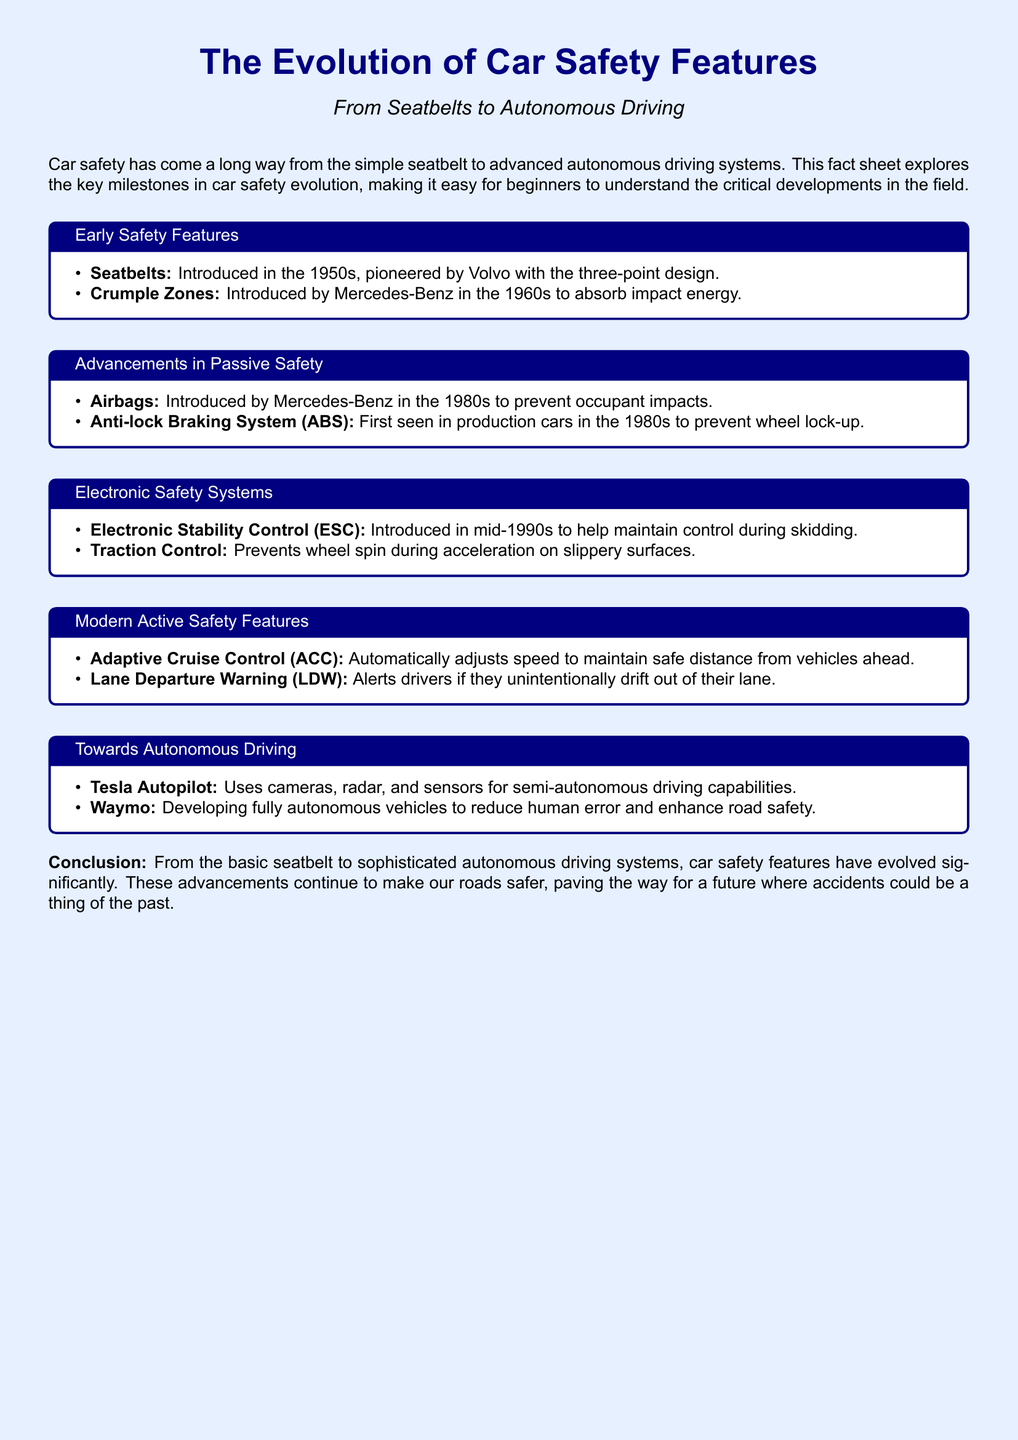What safety feature was introduced in the 1950s? The feature introduced in the 1950s was the seatbelt, pioneered by Volvo with the three-point design.
Answer: Seatbelts Which company introduced crumple zones? Crumple zones were introduced by Mercedes-Benz in the 1960s to absorb impact energy.
Answer: Mercedes-Benz When were airbags first introduced? Airbags were first introduced in the 1980s by Mercedes-Benz to prevent occupant impacts.
Answer: 1980s What does ESC stand for? ESC stands for Electronic Stability Control, introduced in the mid-1990s to help maintain control during skidding.
Answer: Electronic Stability Control What is the purpose of Adaptive Cruise Control? The purpose of Adaptive Cruise Control is to automatically adjust speed to maintain a safe distance from vehicles ahead.
Answer: Maintain safe distance Which features are considered modern active safety features? Adaptive Cruise Control and Lane Departure Warning are considered modern active safety features.
Answer: Adaptive Cruise Control, Lane Departure Warning What does Tesla's Autopilot utilize for driving? Tesla's Autopilot utilizes cameras, radar, and sensors for semi-autonomous driving capabilities.
Answer: Cameras, radar, sensors In which decade did anti-lock braking systems become available in production cars? Anti-lock braking systems became available in production cars in the 1980s.
Answer: 1980s What is the main goal of Waymo's development? The main goal of Waymo's development is to create fully autonomous vehicles to reduce human error and enhance road safety.
Answer: Reduce human error Which milestone represents a transition towards autonomous driving? The milestone that represents a transition towards autonomous driving is Tesla Autopilot.
Answer: Tesla Autopilot 